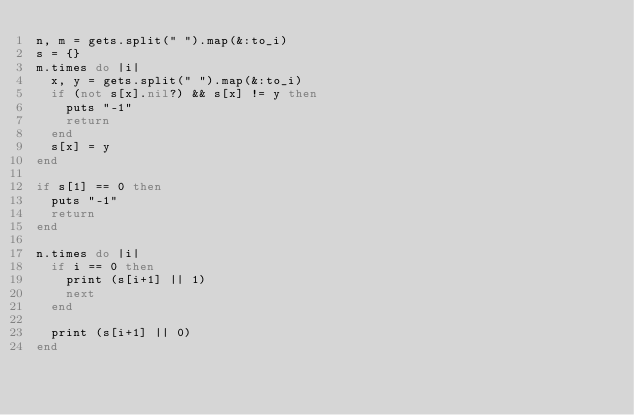Convert code to text. <code><loc_0><loc_0><loc_500><loc_500><_Ruby_>n, m = gets.split(" ").map(&:to_i)
s = {}
m.times do |i|
  x, y = gets.split(" ").map(&:to_i)
  if (not s[x].nil?) && s[x] != y then
    puts "-1"
    return
  end
  s[x] = y
end

if s[1] == 0 then
  puts "-1"
  return
end

n.times do |i|
  if i == 0 then
    print (s[i+1] || 1)
    next
  end

  print (s[i+1] || 0)
end
</code> 